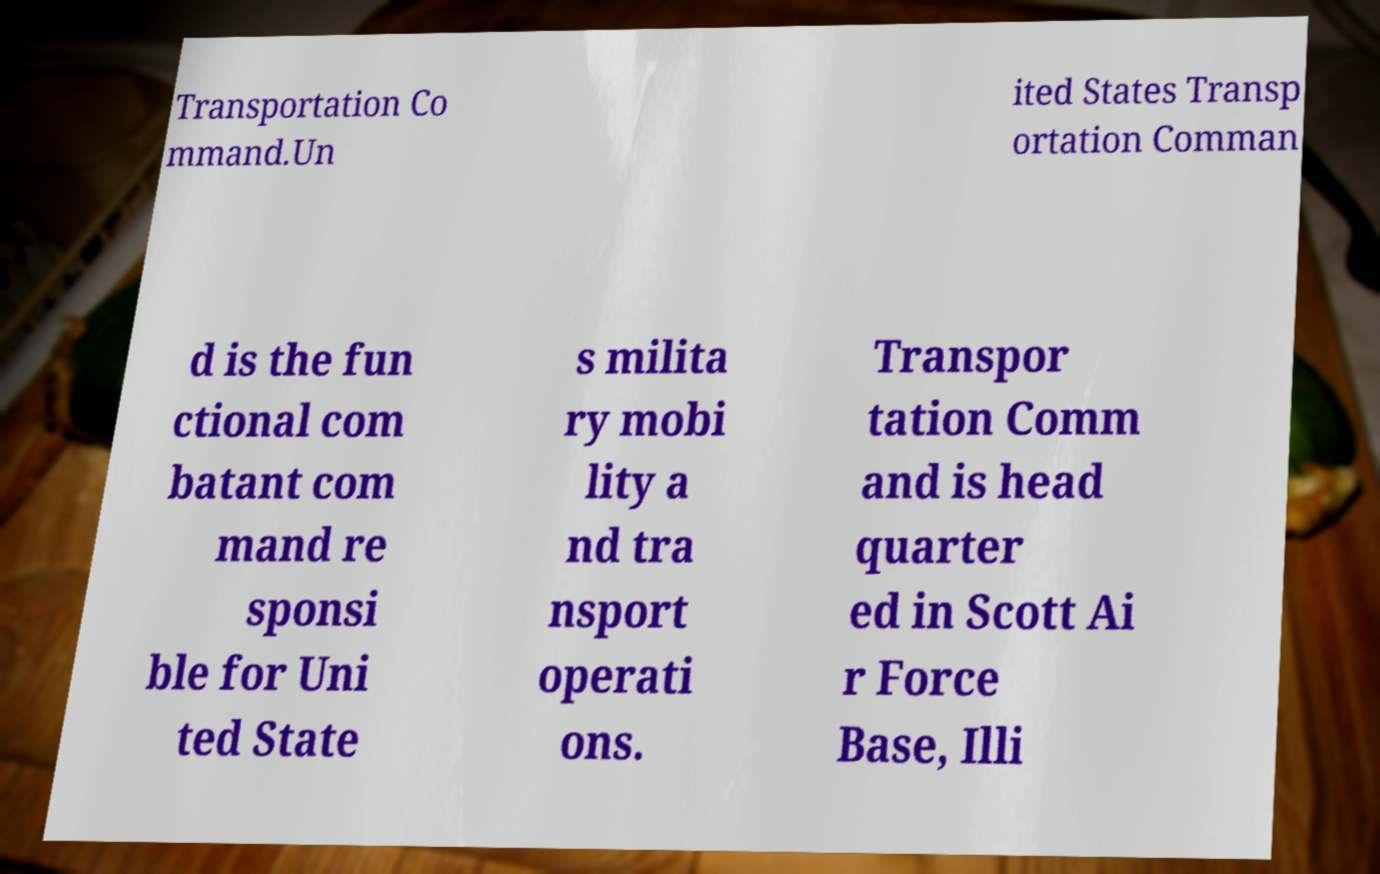For documentation purposes, I need the text within this image transcribed. Could you provide that? Transportation Co mmand.Un ited States Transp ortation Comman d is the fun ctional com batant com mand re sponsi ble for Uni ted State s milita ry mobi lity a nd tra nsport operati ons. Transpor tation Comm and is head quarter ed in Scott Ai r Force Base, Illi 